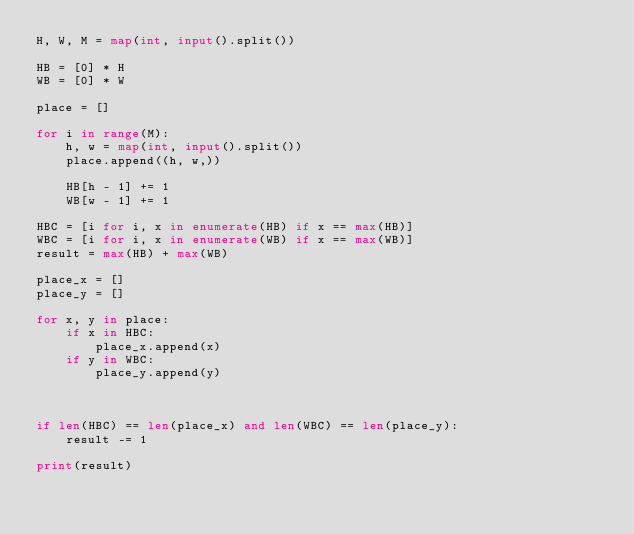Convert code to text. <code><loc_0><loc_0><loc_500><loc_500><_Python_>H, W, M = map(int, input().split())
 
HB = [0] * H
WB = [0] * W
 
place = []
 
for i in range(M):
    h, w = map(int, input().split())
    place.append((h, w,))
 
    HB[h - 1] += 1
    WB[w - 1] += 1
 
HBC = [i for i, x in enumerate(HB) if x == max(HB)]
WBC = [i for i, x in enumerate(WB) if x == max(WB)]
result = max(HB) + max(WB)

place_x = []
place_y = []
 
for x, y in place:
    if x in HBC:
        place_x.append(x)
    if y in WBC:
        place_y.append(y)


 
if len(HBC) == len(place_x) and len(WBC) == len(place_y):
    result -= 1
 
print(result)</code> 